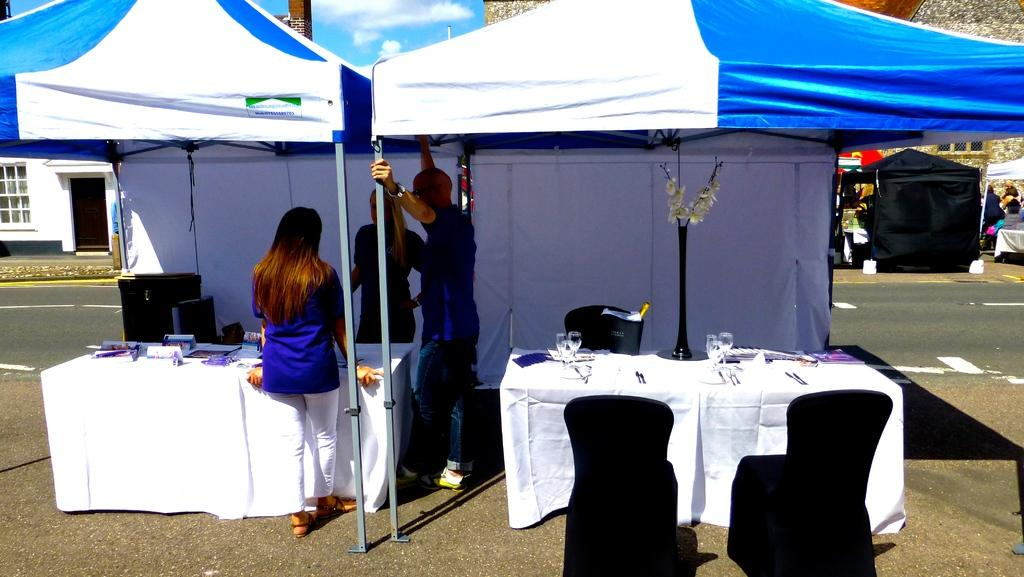What can be seen near the people in the image? There are tables in the image near the people. What type of temporary shelters are present in the image? There are tents in the image. What furniture is visible in the image? Chairs are visible in the image. What is on the table in the image? There are things on the table in the image. What can be seen in the background of the image? There are buildings, clouds, and the sky visible in the background of the image. Can you tell me how many haircuts are being given in the image? There is no haircut being given in the image; it features people standing near tables and tents. What type of fruit is being served on the table in the image? There is no fruit present on the table in the image. 